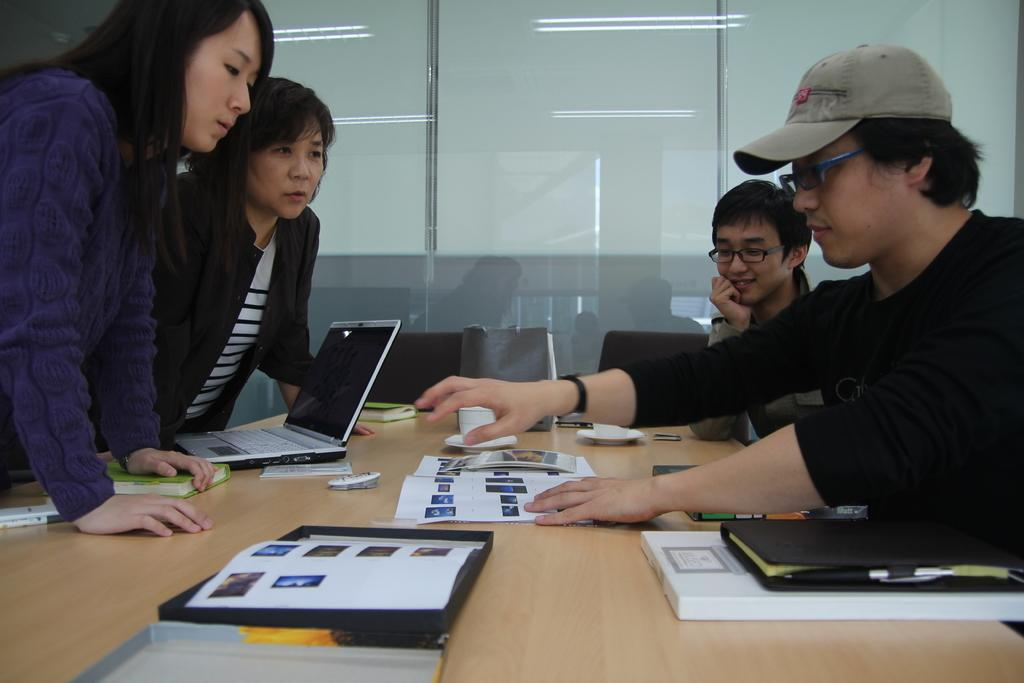How many people are in the image? There are four persons in the image. What are the positions of the men in the image? Two men are standing. What are the positions of the women in the image? Two women are sitting. What is on the table in the image? There is a laptop, papers, and books on the table. What type of machine can be seen in the image? There is no machine visible in the image. How does the laptop in the image help the beginner learn to swim? The laptop in the image is not related to learning to swim, and there is no indication that it is used for that purpose. 